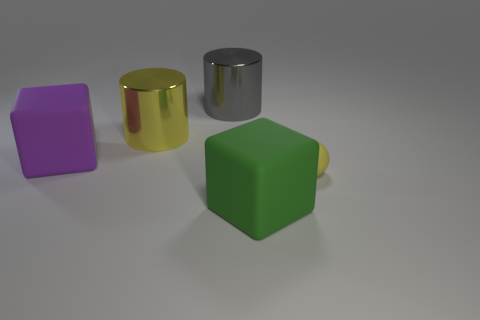Can you tell what the lighting condition is like in this scene? The scene seems to be evenly lit with soft shadows, suggesting diffuse lighting, possibly from an overhead source. 